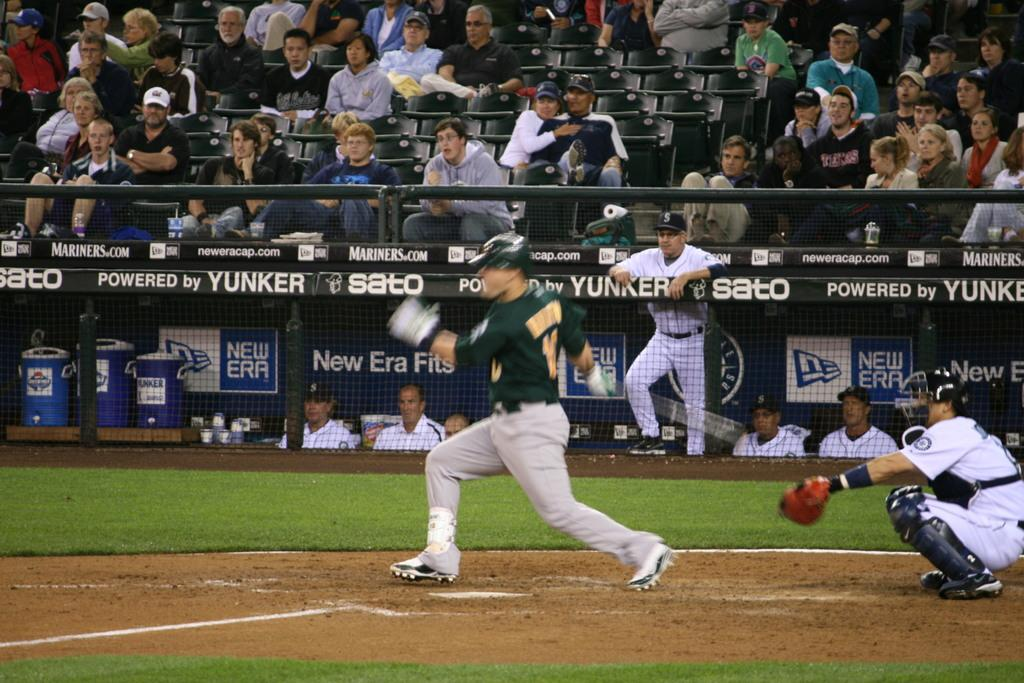<image>
Summarize the visual content of the image. a baseball field with a side line that says 'yunker' on it 